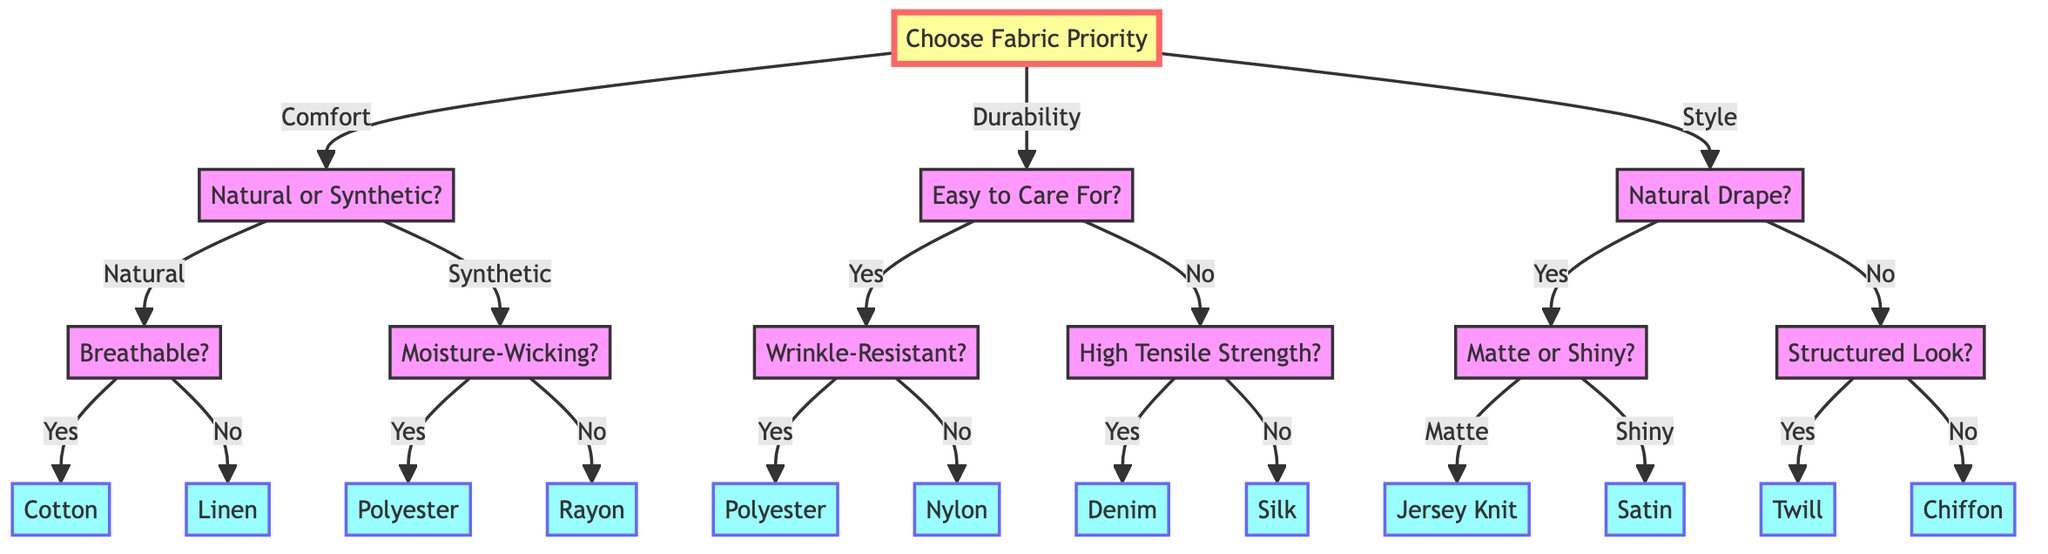What is the top priority when choosing a fabric for a summer dress? The decision tree's first node shows three options: Comfort, Durability, and Style. Therefore, the top priority is one of these three.
Answer: Comfort, Durability, or Style What fabric is recommended if the preference is for natural fibers and breathability? Following the path from the initial question about priority to Comfort, then Natural fibers, and lastly Breathable, the recommended fabric is Cotton.
Answer: Cotton How many options are available under the Style priority? Under the Style category, there are two questions: Natural Drape and Structured Look. Each question leads to two fabric options. In total, there are two main questions, leading to four possible fabric recommendations. Thus, there are four fabric options.
Answer: Four If durability is favored and the fabric needs to be wrinkle-resistant, what fabric is recommended? Following the path of Durability, then Easy to Care For, then Wrinkle-Resistant, the recommendation at the end of this path is Polyester.
Answer: Polyester What fabric should be chosen if comfort is the main priority but a synthetic fiber is preferred and moisture-wicking is not needed? Starting from Comfort, then choosing Synthetic fibers, and then stating that moisture-wicking is not needed leads to Rayon. Following the decisions through the tree results in choosing Rayon.
Answer: Rayon What is the final fabric choice if Style is prioritized and the preference is for a shiny finish? From the decision tree, selecting Style leads to Natural Drape, and then choosing Shiny results in Satin. Thus, the final fabric choice through this pathway is Satin.
Answer: Satin Which fabric option is designated if high tensile strength is required under the Durability category? In the flow from the Durability section, selecting High Tensile Strength leads to Denim as the designated fabric option.
Answer: Denim How many total fabrics can be selected based on the decisions in the flowchart? By counting all possible final fabric outcomes from each path in the decision tree (there are eight fabric options as outcomes), it can be concluded that there are eight possible fabric selections in total.
Answer: Eight 